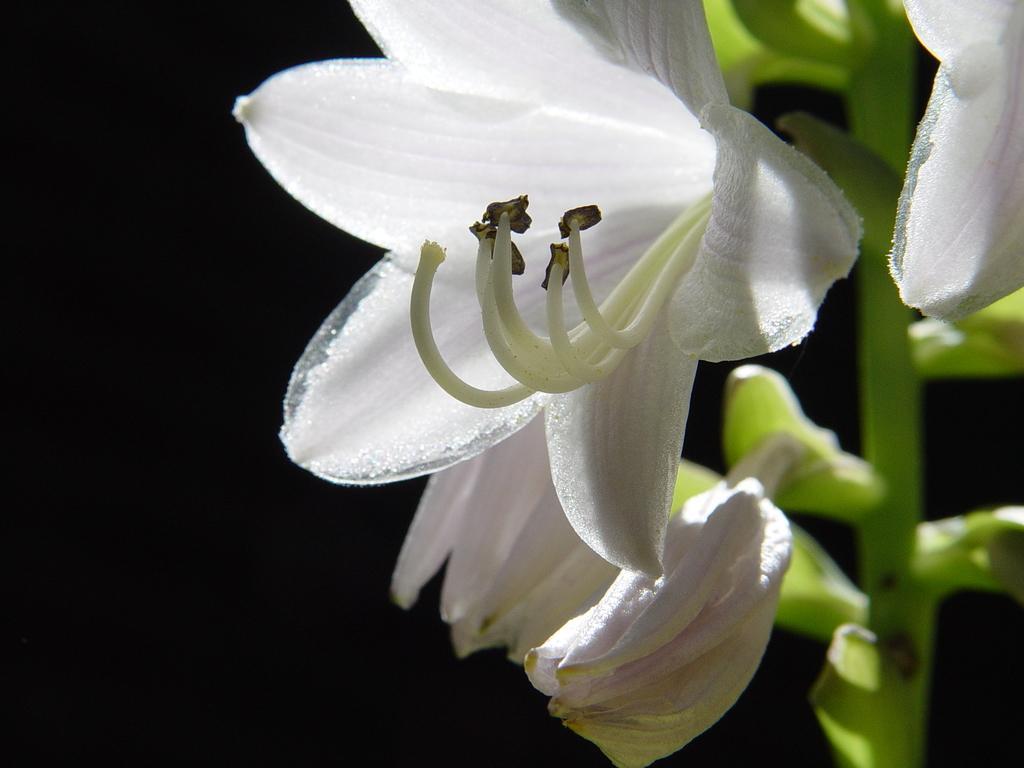Please provide a concise description of this image. In this image we can see flowers and a dark background. 